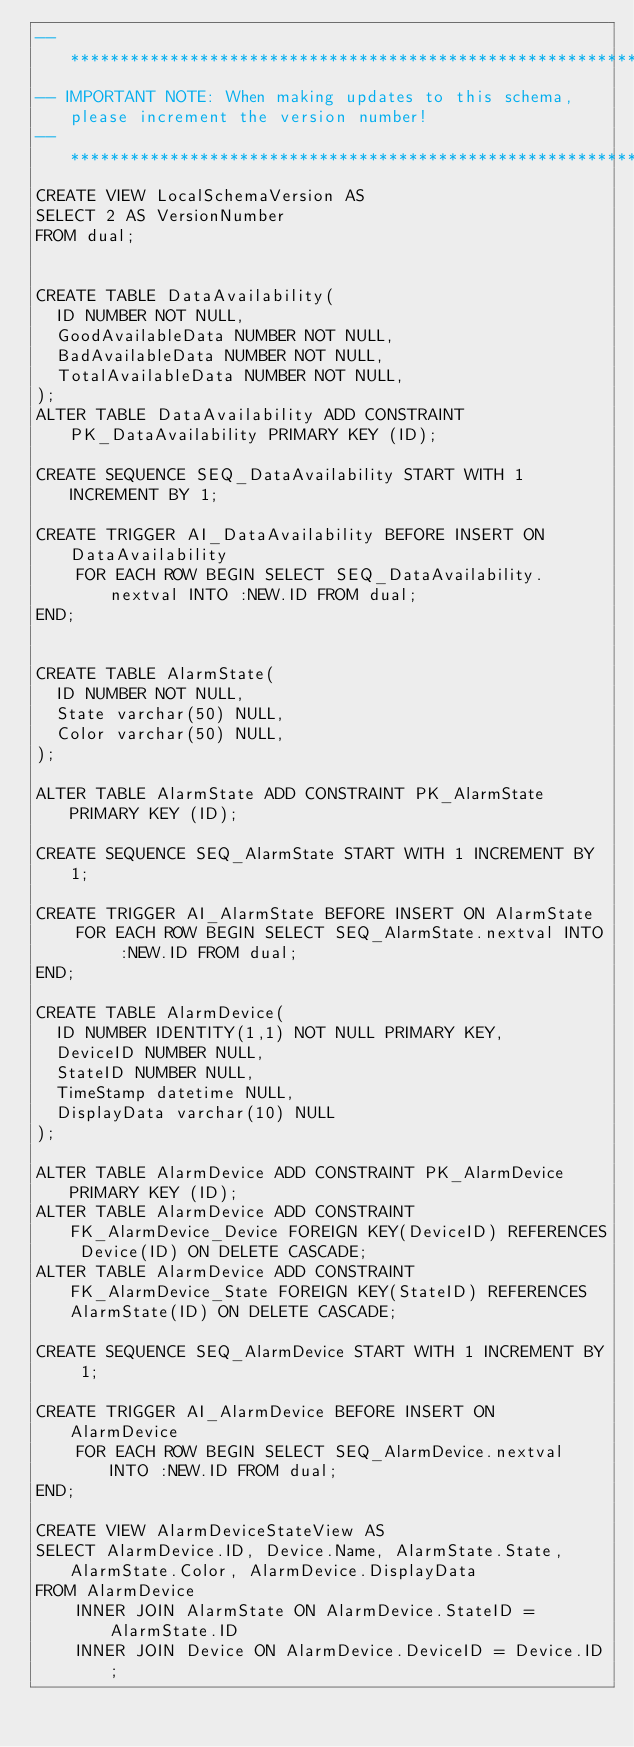Convert code to text. <code><loc_0><loc_0><loc_500><loc_500><_SQL_>-- *******************************************************************************************
-- IMPORTANT NOTE: When making updates to this schema, please increment the version number!
-- *******************************************************************************************
CREATE VIEW LocalSchemaVersion AS
SELECT 2 AS VersionNumber
FROM dual;


CREATE TABLE DataAvailability(
	ID NUMBER NOT NULL,
	GoodAvailableData NUMBER NOT NULL,
	BadAvailableData NUMBER NOT NULL,
	TotalAvailableData NUMBER NOT NULL,
);
ALTER TABLE DataAvailability ADD CONSTRAINT PK_DataAvailability PRIMARY KEY (ID);

CREATE SEQUENCE SEQ_DataAvailability START WITH 1 INCREMENT BY 1;

CREATE TRIGGER AI_DataAvailability BEFORE INSERT ON DataAvailability
    FOR EACH ROW BEGIN SELECT SEQ_DataAvailability.nextval INTO :NEW.ID FROM dual;
END;


CREATE TABLE AlarmState(
	ID NUMBER NOT NULL,
	State varchar(50) NULL,
	Color varchar(50) NULL,
);

ALTER TABLE AlarmState ADD CONSTRAINT PK_AlarmState PRIMARY KEY (ID);

CREATE SEQUENCE SEQ_AlarmState START WITH 1 INCREMENT BY 1;

CREATE TRIGGER AI_AlarmState BEFORE INSERT ON AlarmState
    FOR EACH ROW BEGIN SELECT SEQ_AlarmState.nextval INTO :NEW.ID FROM dual;
END;

CREATE TABLE AlarmDevice(
	ID NUMBER IDENTITY(1,1) NOT NULL PRIMARY KEY,
	DeviceID NUMBER NULL,
	StateID NUMBER NULL,
	TimeStamp datetime NULL,
	DisplayData varchar(10) NULL
);

ALTER TABLE AlarmDevice ADD CONSTRAINT PK_AlarmDevice PRIMARY KEY (ID);
ALTER TABLE AlarmDevice ADD CONSTRAINT FK_AlarmDevice_Device FOREIGN KEY(DeviceID) REFERENCES Device(ID) ON DELETE CASCADE;
ALTER TABLE AlarmDevice ADD CONSTRAINT FK_AlarmDevice_State FOREIGN KEY(StateID) REFERENCES AlarmState(ID) ON DELETE CASCADE;

CREATE SEQUENCE SEQ_AlarmDevice START WITH 1 INCREMENT BY 1;

CREATE TRIGGER AI_AlarmDevice BEFORE INSERT ON AlarmDevice
    FOR EACH ROW BEGIN SELECT SEQ_AlarmDevice.nextval INTO :NEW.ID FROM dual;
END;

CREATE VIEW AlarmDeviceStateView AS
SELECT AlarmDevice.ID, Device.Name, AlarmState.State, AlarmState.Color, AlarmDevice.DisplayData
FROM AlarmDevice
    INNER JOIN AlarmState ON AlarmDevice.StateID = AlarmState.ID
    INNER JOIN Device ON AlarmDevice.DeviceID = Device.ID;</code> 